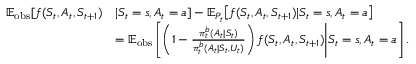<formula> <loc_0><loc_0><loc_500><loc_500>\begin{array} { r l } { \mathbb { E } _ { o b s } [ f ( S _ { t } , A _ { t } , S _ { t + 1 } ) } & { | S _ { t } = s , A _ { t } = a ] - \mathbb { E } _ { P _ { t } } \Big [ f ( S _ { t } , A _ { t } , S _ { t + 1 } ) | S _ { t } = s , A _ { t } = a \Big ] } \\ & { = \mathbb { E } _ { o b s } \left [ \left ( 1 - \frac { \pi _ { t } ^ { b } ( A _ { t } | S _ { t } ) } { \pi _ { t } ^ { b } ( A _ { t } | S _ { t } , U _ { t } ) } \right ) f ( S _ { t } , A _ { t } , S _ { t + 1 } ) \Big | S _ { t } = s , A _ { t } = a \right ] . } \end{array}</formula> 